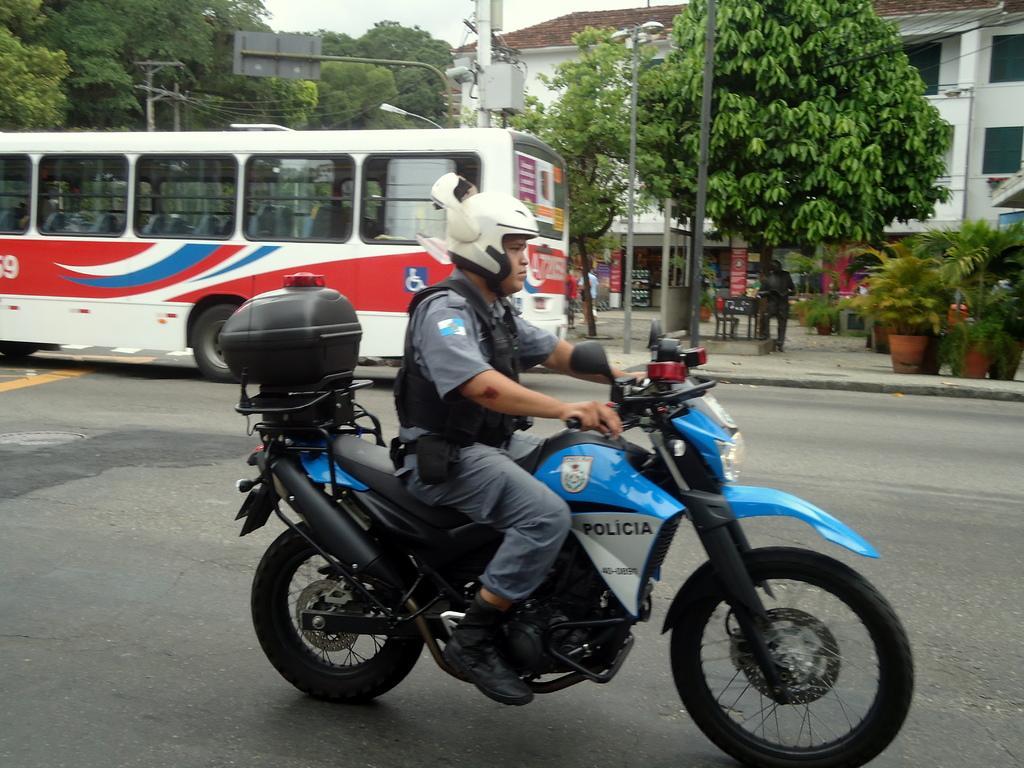Could you give a brief overview of what you see in this image? In this picture there is a man riding a bike on a road. He is wearing a white helmet, black jacket, grey shirt, grey trousers and black shoes. There is a tool kit behind him. In the background there is a bus, tree, plants and a building. 